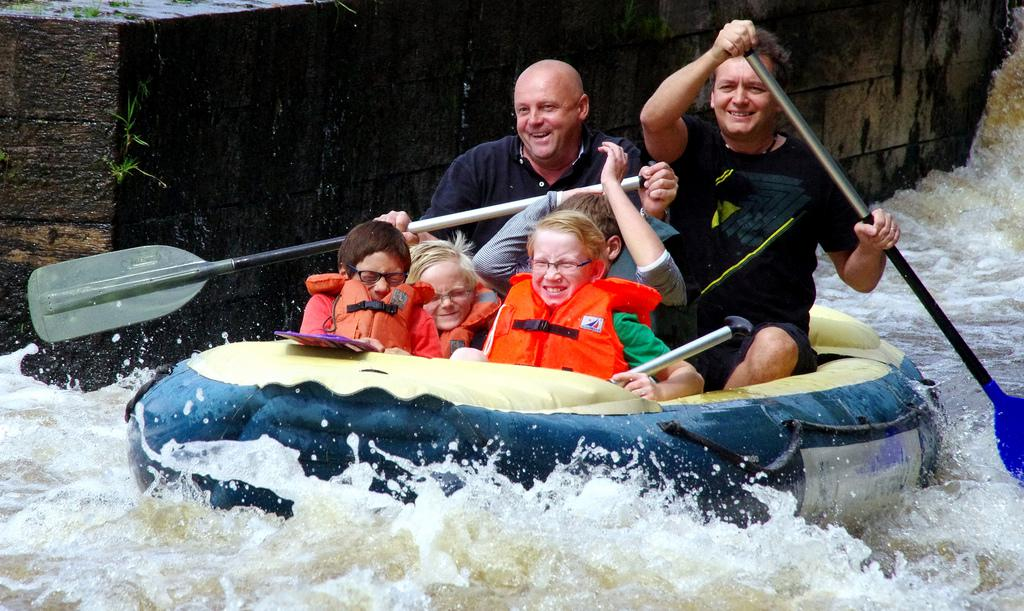Question: who is in this picture?
Choices:
A. Several people.
B. Three men.
C. A large family.
D. Two students.
Answer with the letter. Answer: A Question: when was this picture taken?
Choices:
A. Day time.
B. At noon.
C. After lunch.
D. Night time.
Answer with the letter. Answer: A Question: what are they sitting on?
Choices:
A. A park bench.
B. A sofa.
C. A raft.
D. A loveseat.
Answer with the letter. Answer: C Question: how many people are on the raft?
Choices:
A. Two.
B. Four.
C. Ten.
D. Six.
Answer with the letter. Answer: D Question: who has their eyes closed?
Choices:
A. The woman.
B. The baby.
C. Some of the kids.
D. The man.
Answer with the letter. Answer: C Question: what color water vests are the kids wearing?
Choices:
A. Orange.
B. Red.
C. Yellow.
D. White.
Answer with the letter. Answer: A Question: who are dressed in dark colors?
Choices:
A. The adults.
B. The Amish people.
C. A priest.
D. A lady.
Answer with the letter. Answer: A Question: where are the adults and children?
Choices:
A. At the movies.
B. At a restaurant.
C. Driving in a car.
D. On water rapids.
Answer with the letter. Answer: D Question: who are wearing life vests?
Choices:
A. A fisherman.
B. The children.
C. The adults on a boat.
D. The Coast guard.
Answer with the letter. Answer: B Question: who are wearing life jackets?
Choices:
A. A boater.
B. The children.
C. A lifeguard.
D. A dog.
Answer with the letter. Answer: B Question: who are steering the raft?
Choices:
A. The adults.
B. The guide.
C. The boy scouts.
D. The girl scouts.
Answer with the letter. Answer: A Question: who are not wearing safety gear?
Choices:
A. The adults.
B. The captain of the boat.
C. The children.
D. Teenagers.
Answer with the letter. Answer: A Question: where was this picture taken?
Choices:
A. On a lake.
B. In a pool.
C. In a raft.
D. On the river.
Answer with the letter. Answer: C Question: what is yellow and blue?
Choices:
A. Car.
B. Desk.
C. Boat.
D. Dress.
Answer with the letter. Answer: C Question: what are adults doing?
Choices:
A. Swimming.
B. Scuba diving.
C. Rowing boat.
D. Treasure hunting.
Answer with the letter. Answer: C Question: how is the water?
Choices:
A. Cold.
B. Wavy.
C. Strong.
D. Rough.
Answer with the letter. Answer: D Question: who is bald?
Choices:
A. The younger man.
B. The older man.
C. The older woman.
D. The baby.
Answer with the letter. Answer: B Question: when did the scene occur?
Choices:
A. Daytime.
B. Sunrise.
C. Sunset.
D. Afternoon.
Answer with the letter. Answer: A 